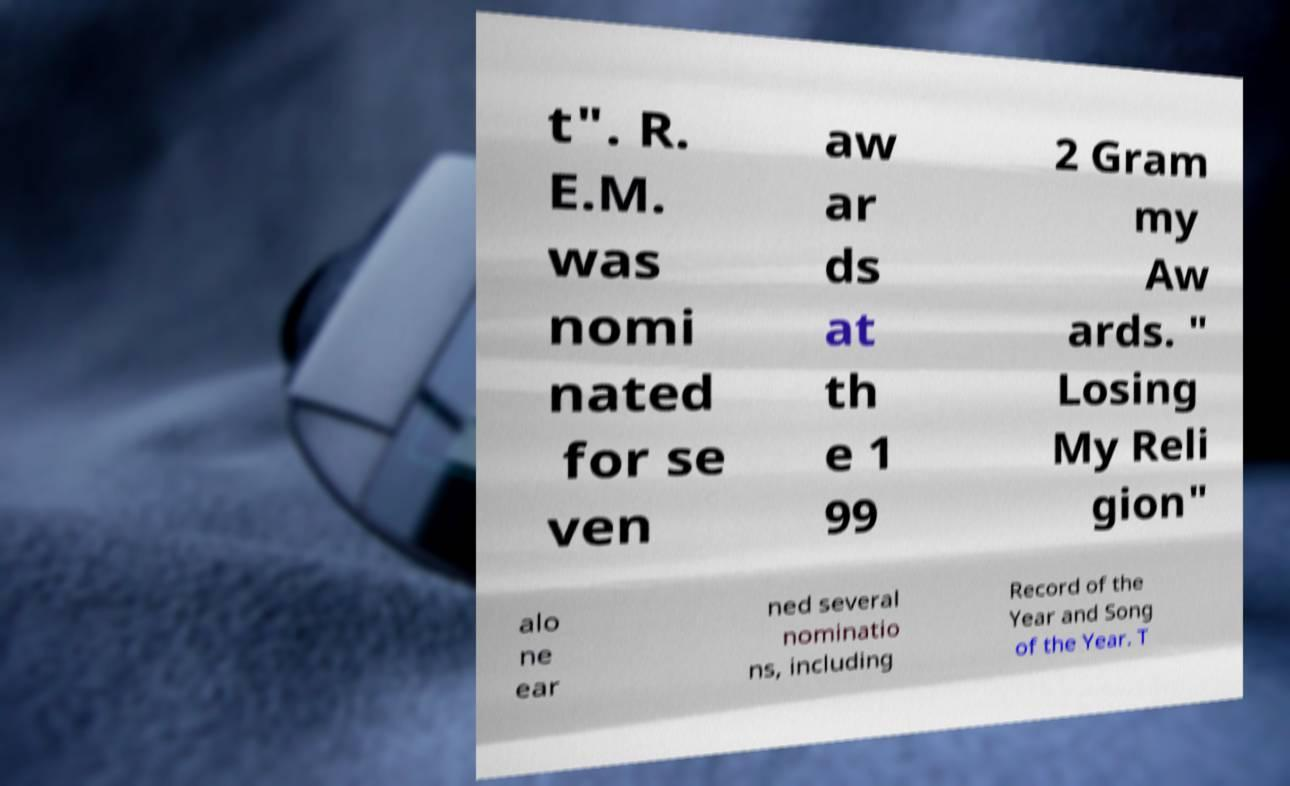Please read and relay the text visible in this image. What does it say? t". R. E.M. was nomi nated for se ven aw ar ds at th e 1 99 2 Gram my Aw ards. " Losing My Reli gion" alo ne ear ned several nominatio ns, including Record of the Year and Song of the Year. T 